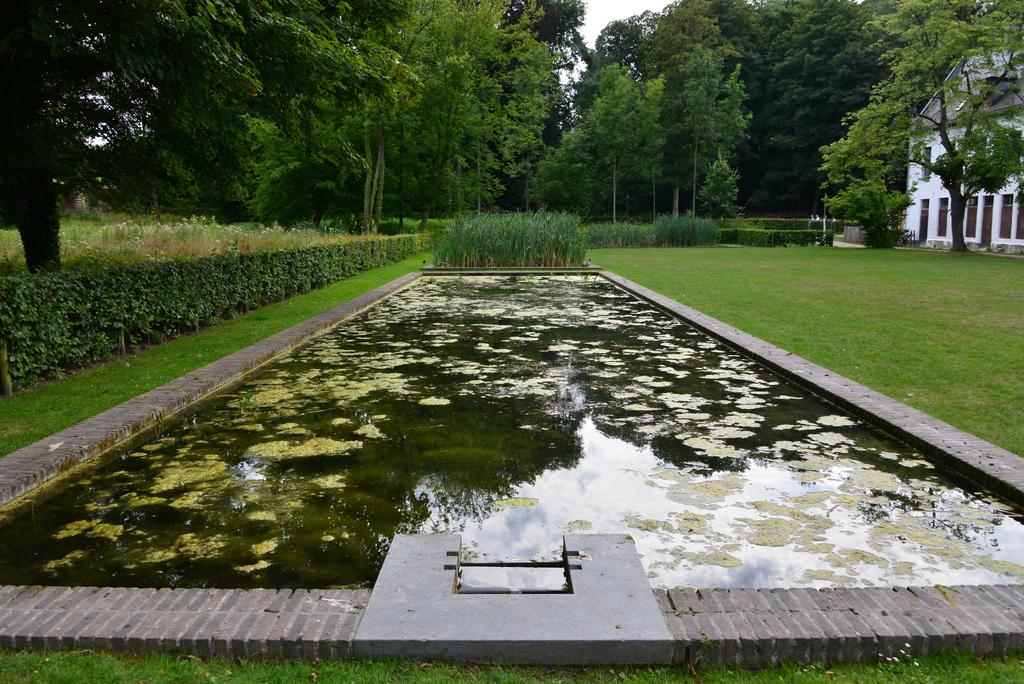What type of natural elements can be seen in the image? There are trees and water visible in the image. What type of man-made structure is present in the image? There is a building in the image. What architectural feature can be seen on the building? There are windows visible on the building. What is the color of the sky in the image? The sky appears to be white in color. Can you see any poisonous plants near the water in the image? There is no mention of poisonous plants in the image, and therefore we cannot determine their presence. Are there any pears hanging from the trees in the image? There is no mention of pears in the image, and therefore we cannot determine their presence. 